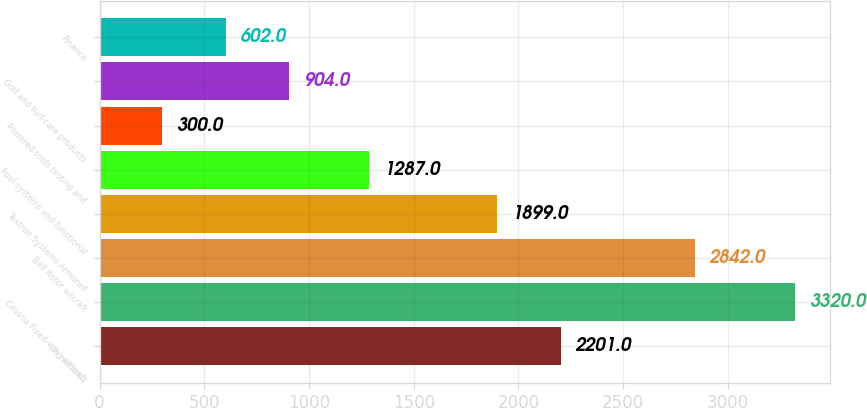Convert chart. <chart><loc_0><loc_0><loc_500><loc_500><bar_chart><fcel>(In millions)<fcel>Cessna Fixed-wing aircraft<fcel>Bell Rotor aircraft<fcel>Textron Systems Armored<fcel>Fuel systems and functional<fcel>Powered tools testing and<fcel>Golf and turf-care products<fcel>Finance<nl><fcel>2201<fcel>3320<fcel>2842<fcel>1899<fcel>1287<fcel>300<fcel>904<fcel>602<nl></chart> 